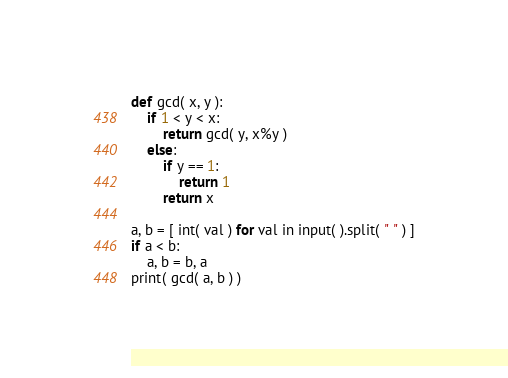<code> <loc_0><loc_0><loc_500><loc_500><_Python_>def gcd( x, y ):
	if 1 < y < x:
		return gcd( y, x%y )
	else:
		if y == 1:
			return 1
		return x

a, b = [ int( val ) for val in input( ).split( " " ) ]
if a < b:
	a, b = b, a
print( gcd( a, b ) )</code> 